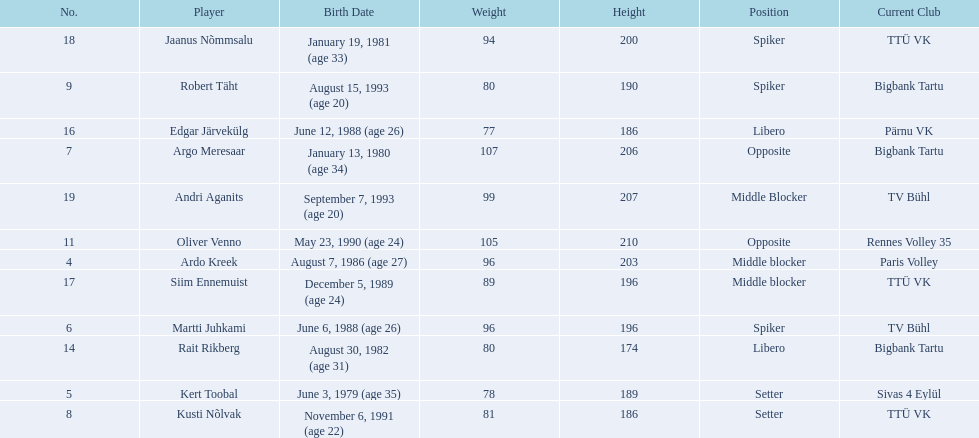Who are the players of the estonian men's national volleyball team? Ardo Kreek, Kert Toobal, Martti Juhkami, Argo Meresaar, Kusti Nõlvak, Robert Täht, Oliver Venno, Rait Rikberg, Edgar Järvekülg, Siim Ennemuist, Jaanus Nõmmsalu, Andri Aganits. Of these, which have a height over 200? Ardo Kreek, Argo Meresaar, Oliver Venno, Andri Aganits. Parse the table in full. {'header': ['No.', 'Player', 'Birth Date', 'Weight', 'Height', 'Position', 'Current Club'], 'rows': [['18', 'Jaanus Nõmmsalu', 'January 19, 1981 (age\xa033)', '94', '200', 'Spiker', 'TTÜ VK'], ['9', 'Robert Täht', 'August 15, 1993 (age\xa020)', '80', '190', 'Spiker', 'Bigbank Tartu'], ['16', 'Edgar Järvekülg', 'June 12, 1988 (age\xa026)', '77', '186', 'Libero', 'Pärnu VK'], ['7', 'Argo Meresaar', 'January 13, 1980 (age\xa034)', '107', '206', 'Opposite', 'Bigbank Tartu'], ['19', 'Andri Aganits', 'September 7, 1993 (age\xa020)', '99', '207', 'Middle Blocker', 'TV Bühl'], ['11', 'Oliver Venno', 'May 23, 1990 (age\xa024)', '105', '210', 'Opposite', 'Rennes Volley 35'], ['4', 'Ardo Kreek', 'August 7, 1986 (age\xa027)', '96', '203', 'Middle blocker', 'Paris Volley'], ['17', 'Siim Ennemuist', 'December 5, 1989 (age\xa024)', '89', '196', 'Middle blocker', 'TTÜ VK'], ['6', 'Martti Juhkami', 'June 6, 1988 (age\xa026)', '96', '196', 'Spiker', 'TV Bühl'], ['14', 'Rait Rikberg', 'August 30, 1982 (age\xa031)', '80', '174', 'Libero', 'Bigbank Tartu'], ['5', 'Kert Toobal', 'June 3, 1979 (age\xa035)', '78', '189', 'Setter', 'Sivas 4 Eylül'], ['8', 'Kusti Nõlvak', 'November 6, 1991 (age\xa022)', '81', '186', 'Setter', 'TTÜ VK']]} Of the remaining, who is the tallest? Oliver Venno. 